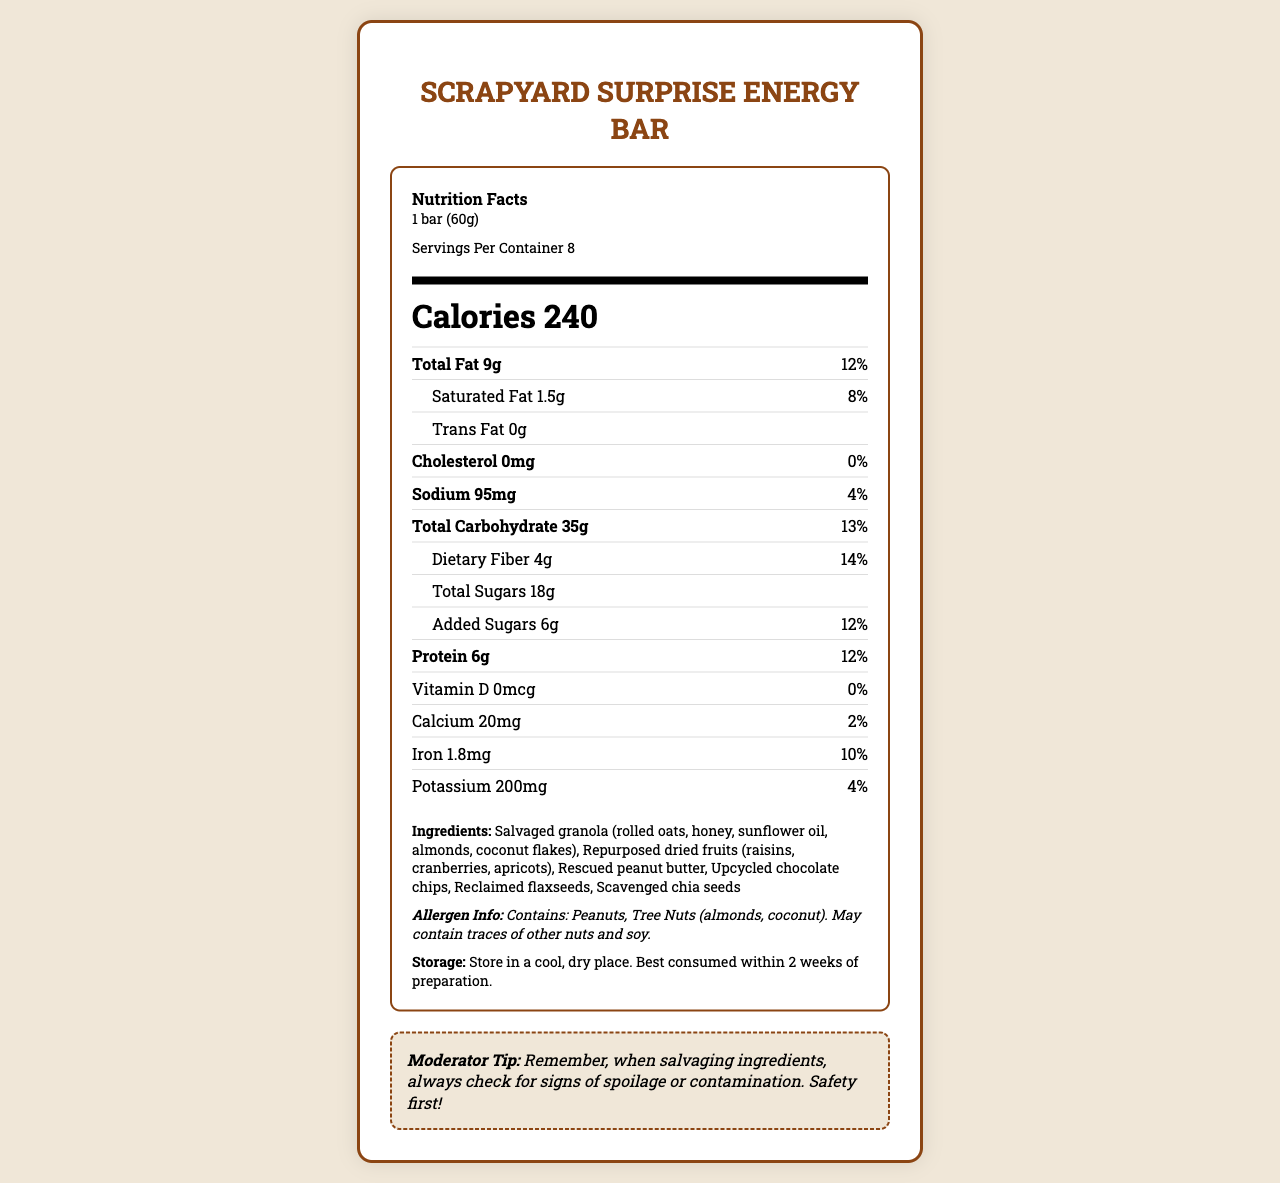What is the serving size of the Scrapyard Surprise Energy Bar? The serving size is clearly noted in the document under the Serving Info section.
Answer: 1 bar (60g) How many calories are in each serving of the energy bar? The calories per serving are prominently displayed in a large font size in the Calories section.
Answer: 240 How much protein does each serving contain? The amount of protein per serving is listed under the Nutrient Row section.
Answer: 6g What percentage of the daily value of iron does each serving provide? The daily value percentage for iron is listed as 10% in the document's nutrient section.
Answer: 10% How much dietary fiber is in one serving? The amount of dietary fiber per serving is specified in the Nutrient Row section under Total Carbohydrate.
Answer: 4g What are the ingredients of the Scrapyard Surprise Energy Bar? The ingredients are listed near the bottom of the document under the Ingredients section.
Answer: Salvaged granola (rolled oats, honey, sunflower oil, almonds, coconut flakes), Repurposed dried fruits (raisins, cranberries, apricots), Rescued peanut butter, Upcycled chocolate chips, Reclaimed flaxseeds, Scavenged chia seeds Does the energy bar contain any trans fats? The document explicitly states that the energy bar contains 0g of trans fats under the Trans Fat section.
Answer: No Which of the following allergens are present in the energy bar? A. Dairy B. Soy C. Peanuts The allergen information in the document states that the bar contains peanuts and tree nuts, but dairy is not mentioned.
Answer: C How much added sugar is in each serving? A. 12g B. 18g C. 6g D. 4g The document specifies that there are 6g of added sugars per serving under the Total Sugars section.
Answer: C Is this energy bar suitable for someone with a peanut allergy? The allergen information clearly states that the bar contains peanuts.
Answer: No Summarize the key nutritional information of the Scrapyard Surprise Energy Bar. The summary captures the essential nutritional values and allergen information, combining the data from various sections of the document.
Answer: The energy bar has 240 calories per serving, with a serving size of 1 bar (60g). Major nutrients include 9g of total fat (12% DV), 6g of protein (12% DV), 35g of total carbohydrates (13% DV), 4g of dietary fiber (14% DV), and 18g of total sugars including 6g of added sugars (12% DV). It contains notable amounts of iron (10% DV) and potassium (4% DV). What is the source of Vitamin D in the energy bar? There is no information on the source of Vitamin D in the document; it only states that each serving has 0mcg of Vitamin D.
Answer: I don't know 